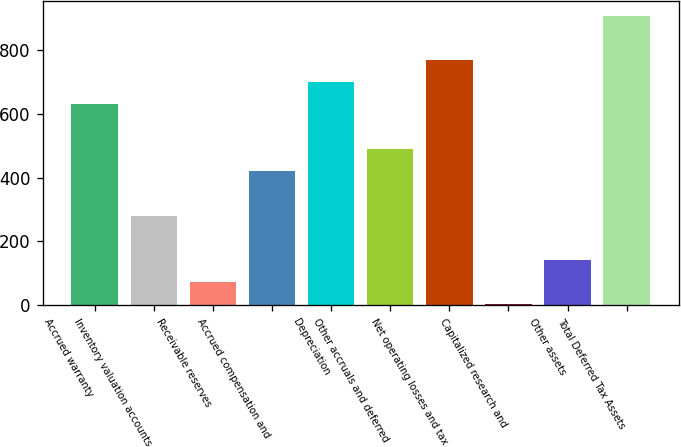Convert chart to OTSL. <chart><loc_0><loc_0><loc_500><loc_500><bar_chart><fcel>Accrued warranty<fcel>Inventory valuation accounts<fcel>Receivable reserves<fcel>Accrued compensation and<fcel>Depreciation<fcel>Other accruals and deferred<fcel>Net operating losses and tax<fcel>Capitalized research and<fcel>Other assets<fcel>Total Deferred Tax Assets<nl><fcel>629.3<fcel>280.8<fcel>71.7<fcel>420.2<fcel>699<fcel>489.9<fcel>768.7<fcel>2<fcel>141.4<fcel>908.1<nl></chart> 